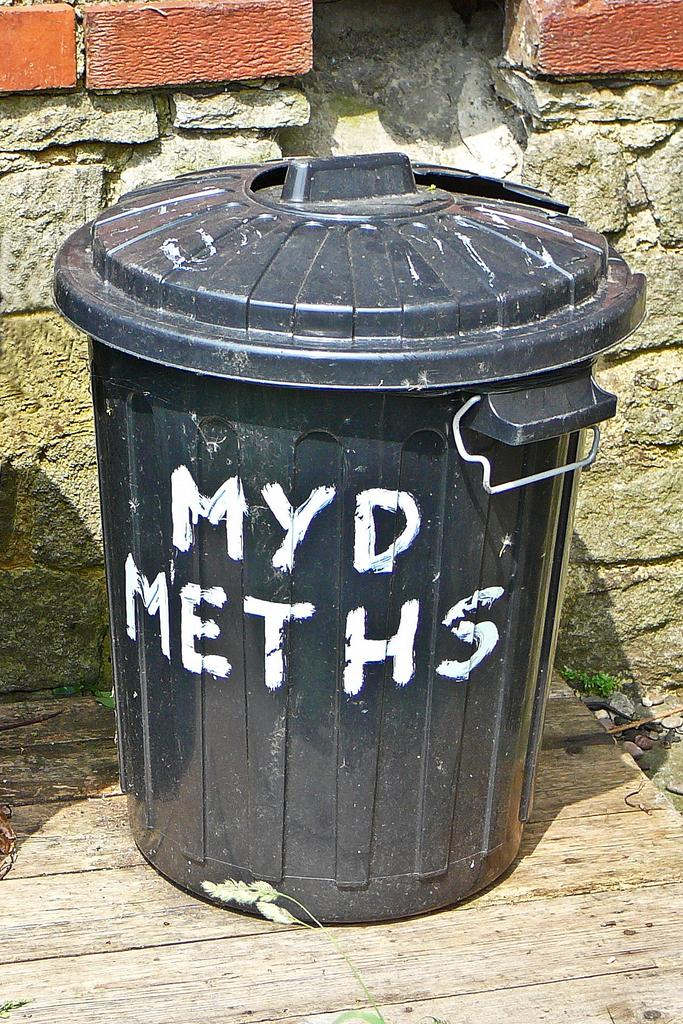<image>
Describe the image concisely. A trash can with white paint writing out MYD Meths 